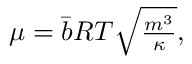Convert formula to latex. <formula><loc_0><loc_0><loc_500><loc_500>\begin{array} { r } { \mu = \bar { b } { R T } \sqrt { \frac { { m ^ { 3 } } } { \kappa } } , } \end{array}</formula> 